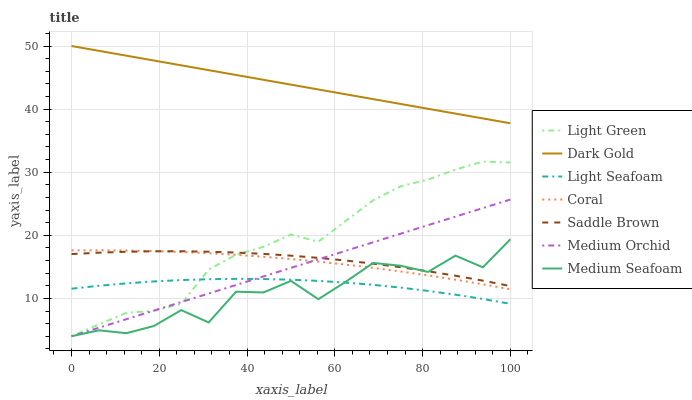Does Coral have the minimum area under the curve?
Answer yes or no. No. Does Coral have the maximum area under the curve?
Answer yes or no. No. Is Coral the smoothest?
Answer yes or no. No. Is Coral the roughest?
Answer yes or no. No. Does Coral have the lowest value?
Answer yes or no. No. Does Coral have the highest value?
Answer yes or no. No. Is Light Seafoam less than Dark Gold?
Answer yes or no. Yes. Is Saddle Brown greater than Light Seafoam?
Answer yes or no. Yes. Does Light Seafoam intersect Dark Gold?
Answer yes or no. No. 